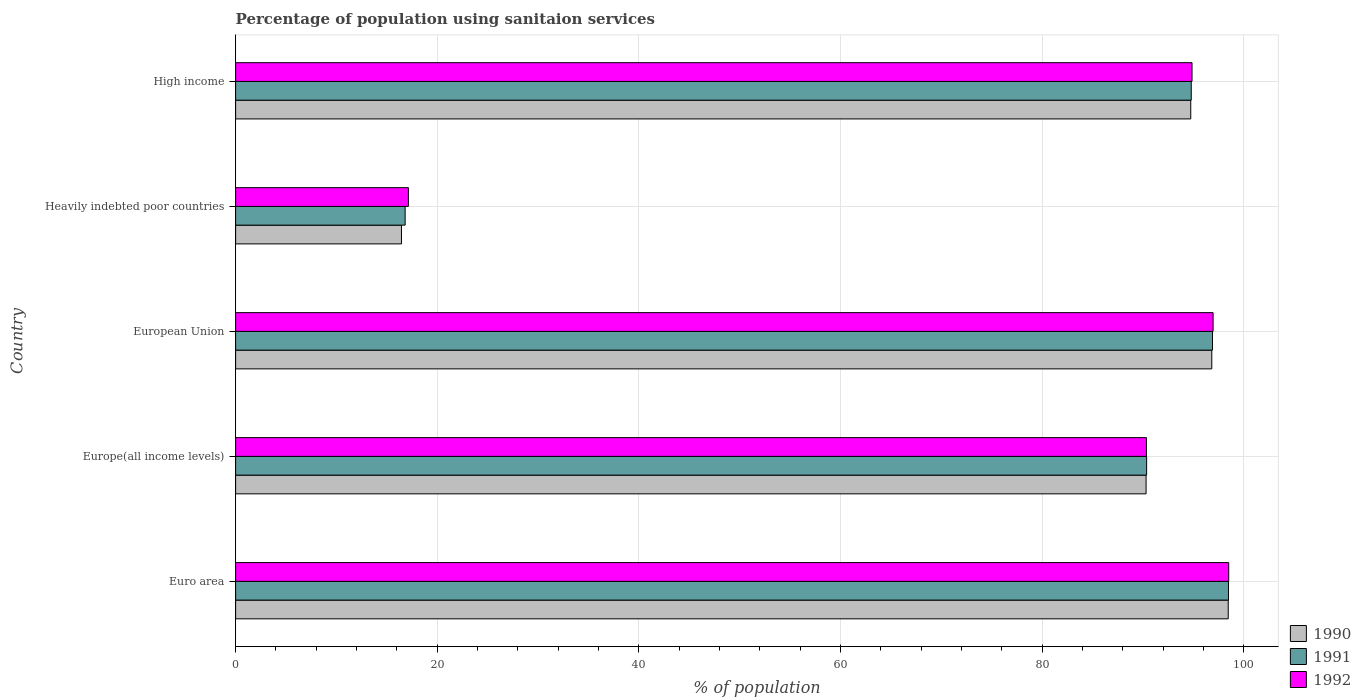How many different coloured bars are there?
Your response must be concise. 3. How many groups of bars are there?
Your answer should be compact. 5. Are the number of bars per tick equal to the number of legend labels?
Offer a very short reply. Yes. What is the label of the 4th group of bars from the top?
Your response must be concise. Europe(all income levels). What is the percentage of population using sanitaion services in 1992 in Heavily indebted poor countries?
Make the answer very short. 17.14. Across all countries, what is the maximum percentage of population using sanitaion services in 1992?
Provide a short and direct response. 98.5. Across all countries, what is the minimum percentage of population using sanitaion services in 1990?
Offer a very short reply. 16.45. In which country was the percentage of population using sanitaion services in 1991 minimum?
Keep it short and to the point. Heavily indebted poor countries. What is the total percentage of population using sanitaion services in 1990 in the graph?
Keep it short and to the point. 396.75. What is the difference between the percentage of population using sanitaion services in 1990 in Europe(all income levels) and that in Heavily indebted poor countries?
Provide a short and direct response. 73.85. What is the difference between the percentage of population using sanitaion services in 1992 in Euro area and the percentage of population using sanitaion services in 1990 in Heavily indebted poor countries?
Ensure brevity in your answer.  82.05. What is the average percentage of population using sanitaion services in 1990 per country?
Make the answer very short. 79.35. What is the difference between the percentage of population using sanitaion services in 1990 and percentage of population using sanitaion services in 1991 in Heavily indebted poor countries?
Offer a very short reply. -0.36. What is the ratio of the percentage of population using sanitaion services in 1991 in European Union to that in High income?
Your response must be concise. 1.02. Is the percentage of population using sanitaion services in 1991 in Euro area less than that in Europe(all income levels)?
Offer a very short reply. No. What is the difference between the highest and the second highest percentage of population using sanitaion services in 1990?
Make the answer very short. 1.63. What is the difference between the highest and the lowest percentage of population using sanitaion services in 1990?
Your response must be concise. 82. Is the sum of the percentage of population using sanitaion services in 1991 in Euro area and High income greater than the maximum percentage of population using sanitaion services in 1990 across all countries?
Your answer should be very brief. Yes. Is it the case that in every country, the sum of the percentage of population using sanitaion services in 1992 and percentage of population using sanitaion services in 1991 is greater than the percentage of population using sanitaion services in 1990?
Give a very brief answer. Yes. How many bars are there?
Provide a short and direct response. 15. What is the difference between two consecutive major ticks on the X-axis?
Your answer should be very brief. 20. Are the values on the major ticks of X-axis written in scientific E-notation?
Give a very brief answer. No. How many legend labels are there?
Ensure brevity in your answer.  3. What is the title of the graph?
Your answer should be very brief. Percentage of population using sanitaion services. Does "1967" appear as one of the legend labels in the graph?
Your answer should be very brief. No. What is the label or title of the X-axis?
Offer a very short reply. % of population. What is the % of population of 1990 in Euro area?
Your answer should be very brief. 98.45. What is the % of population of 1991 in Euro area?
Your response must be concise. 98.47. What is the % of population of 1992 in Euro area?
Your response must be concise. 98.5. What is the % of population of 1990 in Europe(all income levels)?
Your response must be concise. 90.3. What is the % of population of 1991 in Europe(all income levels)?
Your answer should be compact. 90.35. What is the % of population of 1992 in Europe(all income levels)?
Your answer should be very brief. 90.34. What is the % of population of 1990 in European Union?
Your answer should be very brief. 96.82. What is the % of population in 1991 in European Union?
Give a very brief answer. 96.89. What is the % of population of 1992 in European Union?
Keep it short and to the point. 96.95. What is the % of population of 1990 in Heavily indebted poor countries?
Your answer should be very brief. 16.45. What is the % of population in 1991 in Heavily indebted poor countries?
Your answer should be compact. 16.81. What is the % of population of 1992 in Heavily indebted poor countries?
Provide a succinct answer. 17.14. What is the % of population in 1990 in High income?
Provide a short and direct response. 94.73. What is the % of population of 1991 in High income?
Offer a very short reply. 94.78. What is the % of population of 1992 in High income?
Your answer should be compact. 94.86. Across all countries, what is the maximum % of population of 1990?
Your answer should be very brief. 98.45. Across all countries, what is the maximum % of population of 1991?
Make the answer very short. 98.47. Across all countries, what is the maximum % of population in 1992?
Make the answer very short. 98.5. Across all countries, what is the minimum % of population of 1990?
Ensure brevity in your answer.  16.45. Across all countries, what is the minimum % of population of 1991?
Ensure brevity in your answer.  16.81. Across all countries, what is the minimum % of population of 1992?
Your answer should be very brief. 17.14. What is the total % of population of 1990 in the graph?
Provide a succinct answer. 396.75. What is the total % of population of 1991 in the graph?
Offer a terse response. 397.31. What is the total % of population in 1992 in the graph?
Keep it short and to the point. 397.77. What is the difference between the % of population of 1990 in Euro area and that in Europe(all income levels)?
Offer a terse response. 8.15. What is the difference between the % of population in 1991 in Euro area and that in Europe(all income levels)?
Make the answer very short. 8.12. What is the difference between the % of population of 1992 in Euro area and that in Europe(all income levels)?
Give a very brief answer. 8.16. What is the difference between the % of population in 1990 in Euro area and that in European Union?
Provide a succinct answer. 1.63. What is the difference between the % of population of 1991 in Euro area and that in European Union?
Your answer should be compact. 1.59. What is the difference between the % of population of 1992 in Euro area and that in European Union?
Provide a short and direct response. 1.55. What is the difference between the % of population in 1990 in Euro area and that in Heavily indebted poor countries?
Your answer should be compact. 82. What is the difference between the % of population in 1991 in Euro area and that in Heavily indebted poor countries?
Your response must be concise. 81.66. What is the difference between the % of population in 1992 in Euro area and that in Heavily indebted poor countries?
Provide a succinct answer. 81.36. What is the difference between the % of population in 1990 in Euro area and that in High income?
Your response must be concise. 3.72. What is the difference between the % of population of 1991 in Euro area and that in High income?
Your response must be concise. 3.69. What is the difference between the % of population of 1992 in Euro area and that in High income?
Provide a short and direct response. 3.64. What is the difference between the % of population in 1990 in Europe(all income levels) and that in European Union?
Your answer should be compact. -6.52. What is the difference between the % of population of 1991 in Europe(all income levels) and that in European Union?
Give a very brief answer. -6.53. What is the difference between the % of population in 1992 in Europe(all income levels) and that in European Union?
Your answer should be compact. -6.61. What is the difference between the % of population of 1990 in Europe(all income levels) and that in Heavily indebted poor countries?
Keep it short and to the point. 73.85. What is the difference between the % of population in 1991 in Europe(all income levels) and that in Heavily indebted poor countries?
Provide a succinct answer. 73.54. What is the difference between the % of population in 1992 in Europe(all income levels) and that in Heavily indebted poor countries?
Ensure brevity in your answer.  73.2. What is the difference between the % of population in 1990 in Europe(all income levels) and that in High income?
Keep it short and to the point. -4.43. What is the difference between the % of population of 1991 in Europe(all income levels) and that in High income?
Make the answer very short. -4.43. What is the difference between the % of population of 1992 in Europe(all income levels) and that in High income?
Your response must be concise. -4.52. What is the difference between the % of population of 1990 in European Union and that in Heavily indebted poor countries?
Provide a short and direct response. 80.37. What is the difference between the % of population of 1991 in European Union and that in Heavily indebted poor countries?
Offer a very short reply. 80.07. What is the difference between the % of population in 1992 in European Union and that in Heavily indebted poor countries?
Provide a short and direct response. 79.81. What is the difference between the % of population of 1990 in European Union and that in High income?
Offer a very short reply. 2.09. What is the difference between the % of population in 1991 in European Union and that in High income?
Offer a very short reply. 2.11. What is the difference between the % of population of 1992 in European Union and that in High income?
Give a very brief answer. 2.09. What is the difference between the % of population in 1990 in Heavily indebted poor countries and that in High income?
Ensure brevity in your answer.  -78.28. What is the difference between the % of population of 1991 in Heavily indebted poor countries and that in High income?
Your response must be concise. -77.97. What is the difference between the % of population of 1992 in Heavily indebted poor countries and that in High income?
Offer a terse response. -77.72. What is the difference between the % of population in 1990 in Euro area and the % of population in 1991 in Europe(all income levels)?
Give a very brief answer. 8.09. What is the difference between the % of population in 1990 in Euro area and the % of population in 1992 in Europe(all income levels)?
Make the answer very short. 8.11. What is the difference between the % of population in 1991 in Euro area and the % of population in 1992 in Europe(all income levels)?
Make the answer very short. 8.14. What is the difference between the % of population of 1990 in Euro area and the % of population of 1991 in European Union?
Provide a short and direct response. 1.56. What is the difference between the % of population in 1990 in Euro area and the % of population in 1992 in European Union?
Keep it short and to the point. 1.5. What is the difference between the % of population of 1991 in Euro area and the % of population of 1992 in European Union?
Your answer should be very brief. 1.53. What is the difference between the % of population in 1990 in Euro area and the % of population in 1991 in Heavily indebted poor countries?
Your answer should be very brief. 81.64. What is the difference between the % of population in 1990 in Euro area and the % of population in 1992 in Heavily indebted poor countries?
Offer a very short reply. 81.31. What is the difference between the % of population in 1991 in Euro area and the % of population in 1992 in Heavily indebted poor countries?
Your answer should be very brief. 81.34. What is the difference between the % of population in 1990 in Euro area and the % of population in 1991 in High income?
Your answer should be very brief. 3.67. What is the difference between the % of population in 1990 in Euro area and the % of population in 1992 in High income?
Provide a succinct answer. 3.59. What is the difference between the % of population of 1991 in Euro area and the % of population of 1992 in High income?
Offer a terse response. 3.62. What is the difference between the % of population in 1990 in Europe(all income levels) and the % of population in 1991 in European Union?
Provide a short and direct response. -6.59. What is the difference between the % of population of 1990 in Europe(all income levels) and the % of population of 1992 in European Union?
Give a very brief answer. -6.65. What is the difference between the % of population in 1991 in Europe(all income levels) and the % of population in 1992 in European Union?
Give a very brief answer. -6.59. What is the difference between the % of population of 1990 in Europe(all income levels) and the % of population of 1991 in Heavily indebted poor countries?
Your response must be concise. 73.49. What is the difference between the % of population of 1990 in Europe(all income levels) and the % of population of 1992 in Heavily indebted poor countries?
Keep it short and to the point. 73.16. What is the difference between the % of population of 1991 in Europe(all income levels) and the % of population of 1992 in Heavily indebted poor countries?
Give a very brief answer. 73.22. What is the difference between the % of population of 1990 in Europe(all income levels) and the % of population of 1991 in High income?
Make the answer very short. -4.48. What is the difference between the % of population in 1990 in Europe(all income levels) and the % of population in 1992 in High income?
Make the answer very short. -4.56. What is the difference between the % of population of 1991 in Europe(all income levels) and the % of population of 1992 in High income?
Make the answer very short. -4.5. What is the difference between the % of population of 1990 in European Union and the % of population of 1991 in Heavily indebted poor countries?
Give a very brief answer. 80.01. What is the difference between the % of population in 1990 in European Union and the % of population in 1992 in Heavily indebted poor countries?
Give a very brief answer. 79.68. What is the difference between the % of population in 1991 in European Union and the % of population in 1992 in Heavily indebted poor countries?
Offer a very short reply. 79.75. What is the difference between the % of population in 1990 in European Union and the % of population in 1991 in High income?
Your answer should be very brief. 2.04. What is the difference between the % of population in 1990 in European Union and the % of population in 1992 in High income?
Keep it short and to the point. 1.96. What is the difference between the % of population of 1991 in European Union and the % of population of 1992 in High income?
Your answer should be very brief. 2.03. What is the difference between the % of population of 1990 in Heavily indebted poor countries and the % of population of 1991 in High income?
Ensure brevity in your answer.  -78.33. What is the difference between the % of population of 1990 in Heavily indebted poor countries and the % of population of 1992 in High income?
Make the answer very short. -78.41. What is the difference between the % of population in 1991 in Heavily indebted poor countries and the % of population in 1992 in High income?
Provide a succinct answer. -78.04. What is the average % of population in 1990 per country?
Offer a terse response. 79.35. What is the average % of population of 1991 per country?
Ensure brevity in your answer.  79.46. What is the average % of population of 1992 per country?
Make the answer very short. 79.55. What is the difference between the % of population in 1990 and % of population in 1991 in Euro area?
Your answer should be compact. -0.02. What is the difference between the % of population in 1990 and % of population in 1992 in Euro area?
Keep it short and to the point. -0.05. What is the difference between the % of population in 1991 and % of population in 1992 in Euro area?
Your answer should be very brief. -0.02. What is the difference between the % of population in 1990 and % of population in 1991 in Europe(all income levels)?
Your answer should be compact. -0.05. What is the difference between the % of population in 1990 and % of population in 1992 in Europe(all income levels)?
Give a very brief answer. -0.03. What is the difference between the % of population of 1991 and % of population of 1992 in Europe(all income levels)?
Ensure brevity in your answer.  0.02. What is the difference between the % of population in 1990 and % of population in 1991 in European Union?
Offer a terse response. -0.07. What is the difference between the % of population in 1990 and % of population in 1992 in European Union?
Keep it short and to the point. -0.13. What is the difference between the % of population in 1991 and % of population in 1992 in European Union?
Make the answer very short. -0.06. What is the difference between the % of population of 1990 and % of population of 1991 in Heavily indebted poor countries?
Give a very brief answer. -0.36. What is the difference between the % of population in 1990 and % of population in 1992 in Heavily indebted poor countries?
Your response must be concise. -0.69. What is the difference between the % of population of 1991 and % of population of 1992 in Heavily indebted poor countries?
Offer a terse response. -0.32. What is the difference between the % of population in 1990 and % of population in 1991 in High income?
Make the answer very short. -0.05. What is the difference between the % of population of 1990 and % of population of 1992 in High income?
Your answer should be compact. -0.13. What is the difference between the % of population in 1991 and % of population in 1992 in High income?
Provide a succinct answer. -0.08. What is the ratio of the % of population of 1990 in Euro area to that in Europe(all income levels)?
Give a very brief answer. 1.09. What is the ratio of the % of population of 1991 in Euro area to that in Europe(all income levels)?
Your answer should be compact. 1.09. What is the ratio of the % of population in 1992 in Euro area to that in Europe(all income levels)?
Offer a terse response. 1.09. What is the ratio of the % of population of 1990 in Euro area to that in European Union?
Keep it short and to the point. 1.02. What is the ratio of the % of population in 1991 in Euro area to that in European Union?
Your answer should be compact. 1.02. What is the ratio of the % of population of 1990 in Euro area to that in Heavily indebted poor countries?
Your answer should be very brief. 5.99. What is the ratio of the % of population in 1991 in Euro area to that in Heavily indebted poor countries?
Make the answer very short. 5.86. What is the ratio of the % of population of 1992 in Euro area to that in Heavily indebted poor countries?
Provide a short and direct response. 5.75. What is the ratio of the % of population in 1990 in Euro area to that in High income?
Offer a terse response. 1.04. What is the ratio of the % of population in 1991 in Euro area to that in High income?
Give a very brief answer. 1.04. What is the ratio of the % of population in 1992 in Euro area to that in High income?
Your response must be concise. 1.04. What is the ratio of the % of population in 1990 in Europe(all income levels) to that in European Union?
Provide a succinct answer. 0.93. What is the ratio of the % of population of 1991 in Europe(all income levels) to that in European Union?
Offer a terse response. 0.93. What is the ratio of the % of population of 1992 in Europe(all income levels) to that in European Union?
Offer a very short reply. 0.93. What is the ratio of the % of population in 1990 in Europe(all income levels) to that in Heavily indebted poor countries?
Your answer should be very brief. 5.49. What is the ratio of the % of population of 1991 in Europe(all income levels) to that in Heavily indebted poor countries?
Your response must be concise. 5.37. What is the ratio of the % of population in 1992 in Europe(all income levels) to that in Heavily indebted poor countries?
Your answer should be very brief. 5.27. What is the ratio of the % of population in 1990 in Europe(all income levels) to that in High income?
Provide a succinct answer. 0.95. What is the ratio of the % of population in 1991 in Europe(all income levels) to that in High income?
Your answer should be compact. 0.95. What is the ratio of the % of population of 1992 in Europe(all income levels) to that in High income?
Your answer should be compact. 0.95. What is the ratio of the % of population of 1990 in European Union to that in Heavily indebted poor countries?
Give a very brief answer. 5.89. What is the ratio of the % of population in 1991 in European Union to that in Heavily indebted poor countries?
Your answer should be compact. 5.76. What is the ratio of the % of population in 1992 in European Union to that in Heavily indebted poor countries?
Your answer should be compact. 5.66. What is the ratio of the % of population of 1991 in European Union to that in High income?
Keep it short and to the point. 1.02. What is the ratio of the % of population in 1992 in European Union to that in High income?
Provide a short and direct response. 1.02. What is the ratio of the % of population in 1990 in Heavily indebted poor countries to that in High income?
Your response must be concise. 0.17. What is the ratio of the % of population in 1991 in Heavily indebted poor countries to that in High income?
Keep it short and to the point. 0.18. What is the ratio of the % of population of 1992 in Heavily indebted poor countries to that in High income?
Provide a short and direct response. 0.18. What is the difference between the highest and the second highest % of population in 1990?
Offer a very short reply. 1.63. What is the difference between the highest and the second highest % of population of 1991?
Keep it short and to the point. 1.59. What is the difference between the highest and the second highest % of population of 1992?
Offer a terse response. 1.55. What is the difference between the highest and the lowest % of population of 1990?
Your answer should be compact. 82. What is the difference between the highest and the lowest % of population of 1991?
Your answer should be very brief. 81.66. What is the difference between the highest and the lowest % of population of 1992?
Provide a succinct answer. 81.36. 